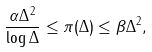Convert formula to latex. <formula><loc_0><loc_0><loc_500><loc_500>\frac { \alpha \Delta ^ { 2 } } { \log \Delta } \leq \pi ( \Delta ) \leq \beta \Delta ^ { 2 } ,</formula> 